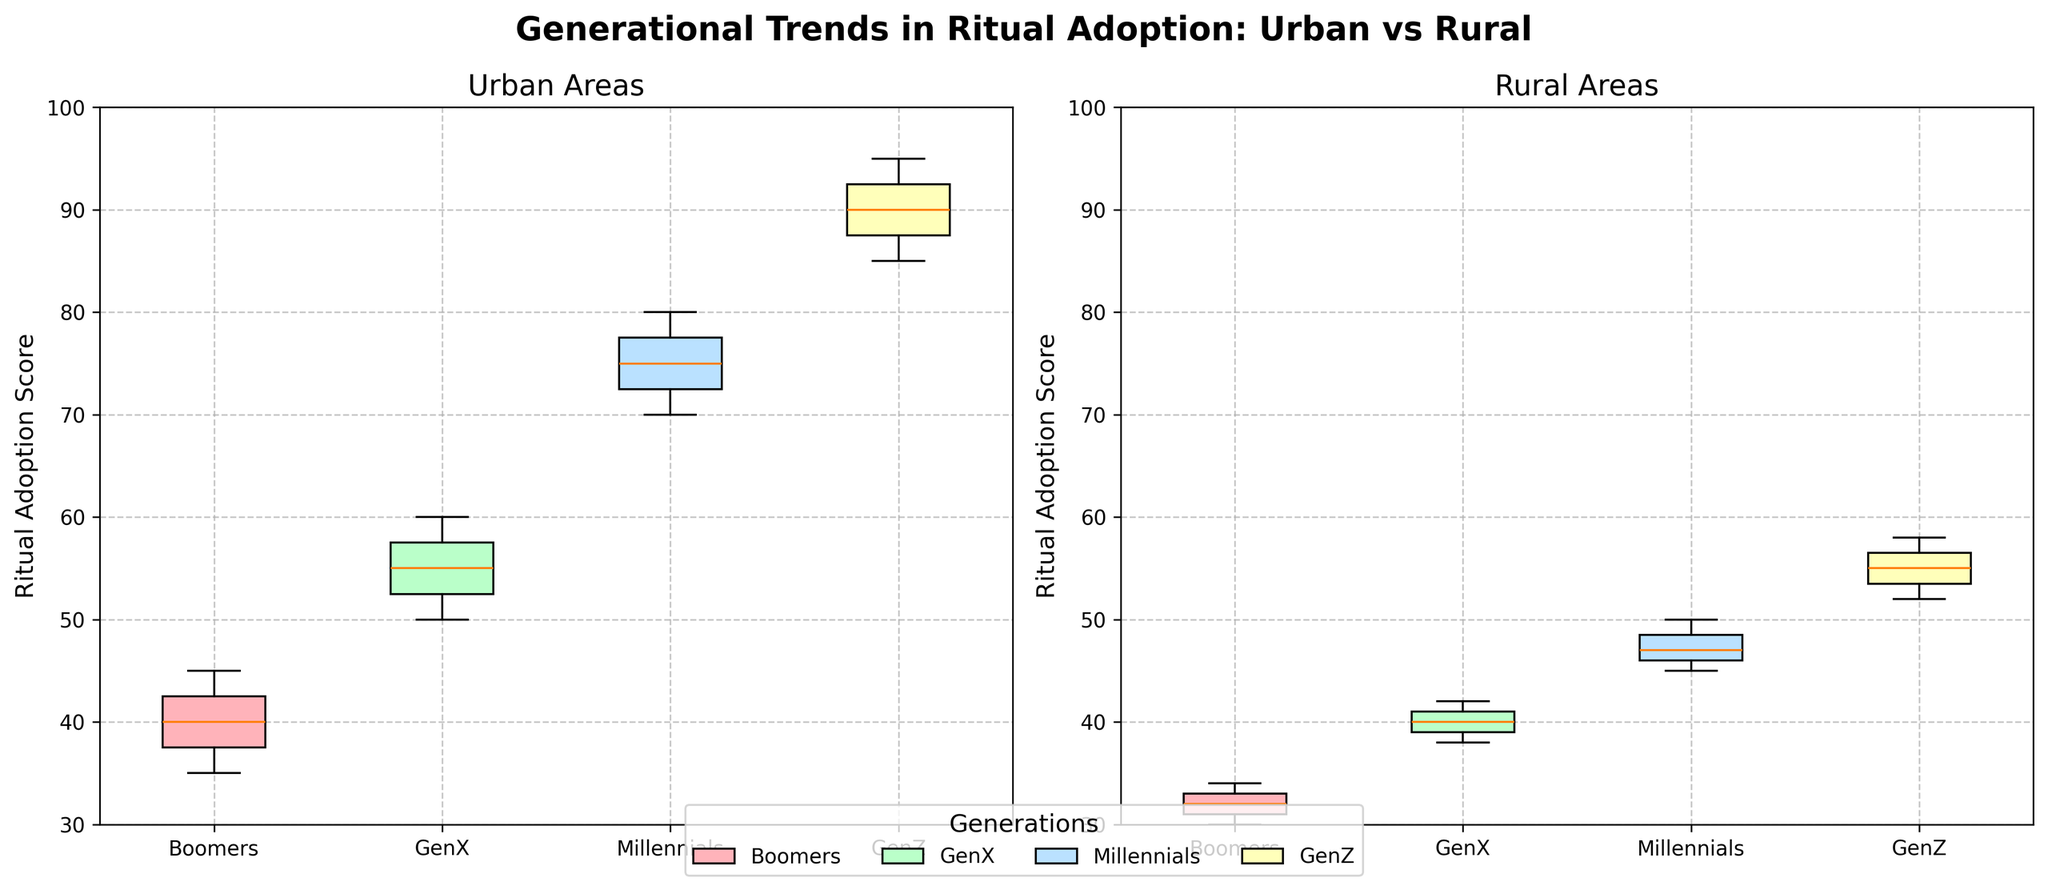Which area shows higher median Ritual Adoption Scores for Boomers, Urban or Rural? By examining the boxes for Boomers in each subplot, we see the median line in the Urban box is higher than the median line in the Rural box.
Answer: Urban What's the difference in the median Ritual Adoption Scores between Urban and Rural GenX? The median line for Urban GenX is at around 55, while for Rural GenX, it is around 40. The difference is 55 - 40.
Answer: 15 How does the interquartile range (IQR) for Urban Millennials compare to the IQR for Rural Millennials? The IQR is represented by the height of the box in the box plot. The Urban Millennials box is taller than the Rural Millennials box, indicating a larger IQR for Urban Millennials.
Answer: Urban Millennials have a larger IQR Which generation has the highest median Ritual Adoption Score in Urban areas? The highest median line among the generations in the Urban subplot is found in GenZ.
Answer: GenZ What is the approximate range of Ritual Adoption Scores for Rural GenZ? The whiskers and outliers indicate the range. For Rural GenZ, the minimum is around 52 and the maximum is about 58.
Answer: 52-58 Compare the adoption spread between Urban and Rural GenX generations. The Urban GenX box is taller and shows a wider spread compared to the shorter Rural GenX box, indicating Urban GenX has more variability in scores.
Answer: Urban GenX has more variability Is there any overlap in the Ritual Adoption Scores between the Urban and Rural Millennials? By comparing the box plots, we see that the scores for Rural Millennials overlap with the lower part of the distribution of Urban Millennials.
Answer: Yes Which generation shows the least variability in Ritual Adoption Scores in Rural areas? The box plots with shorter boxes signify less variability. The Rural Boomers box is the shortest, showing least variability.
Answer: Boomers How does the median Ritual Adoption Score for Urban GenZ compare to the upper quartile of Rural GenZ? The upper quartile for Rural GenZ is lower than the median for Urban GenZ, indicating the former is closer to 58 while the latter is around 90.
Answer: Urban GenZ median is higher What trend can be observed about Ritual Adoption Scores across generations in Urban areas? The median scores increase progressively from Boomers to GenZ, indicating higher ritual adoption in younger generations in Urban areas.
Answer: Increasing trend 